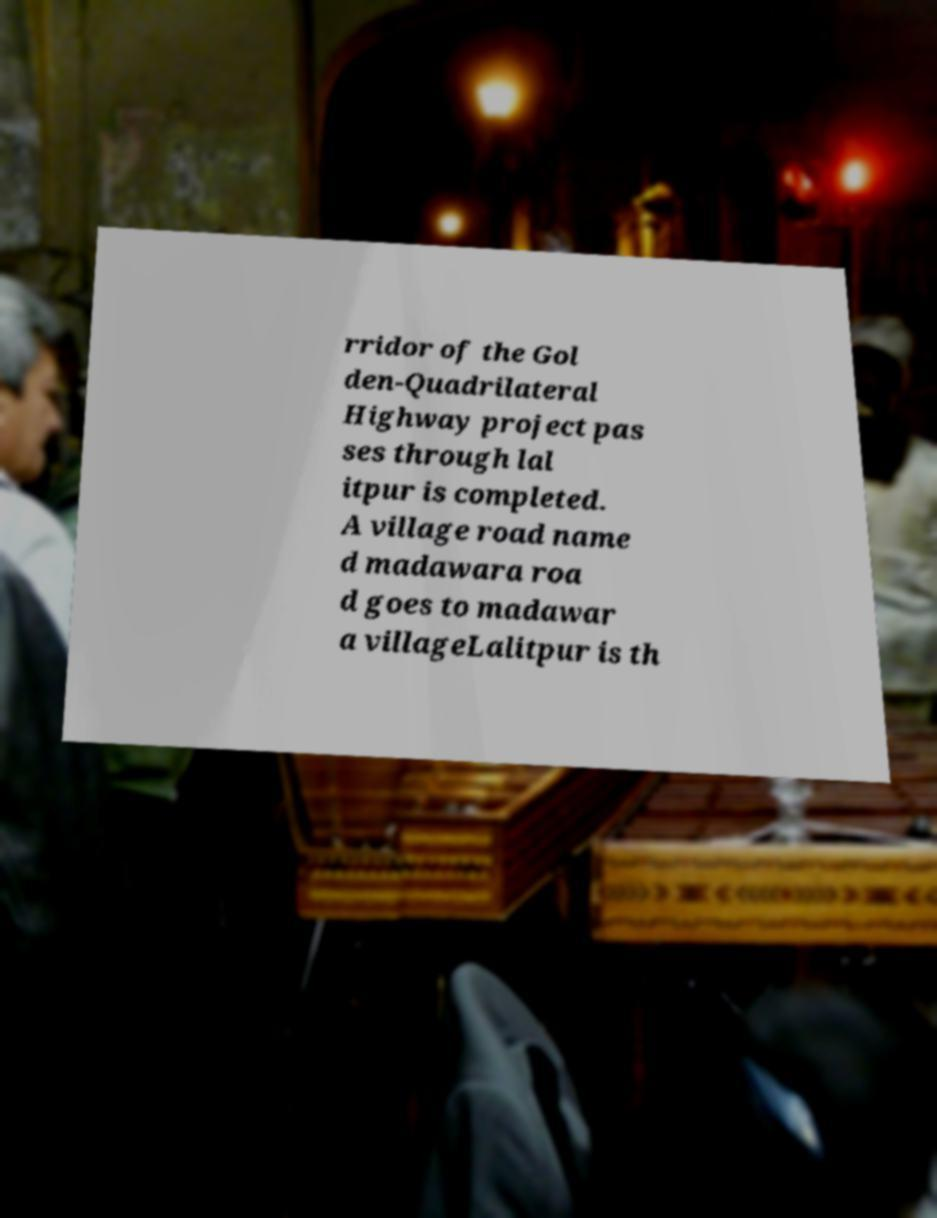Could you extract and type out the text from this image? rridor of the Gol den-Quadrilateral Highway project pas ses through lal itpur is completed. A village road name d madawara roa d goes to madawar a villageLalitpur is th 